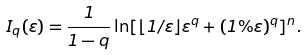Convert formula to latex. <formula><loc_0><loc_0><loc_500><loc_500>I _ { q } ( \varepsilon ) = \frac { 1 } { 1 - q } \ln [ \lfloor 1 / \varepsilon \rfloor \varepsilon ^ { q } + ( 1 \% \varepsilon ) ^ { q } ] ^ { n } .</formula> 